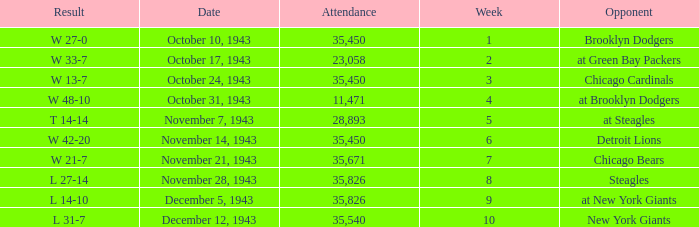What is the lowest attendance that has a week less than 4, and w 13-7 as the result? 35450.0. 